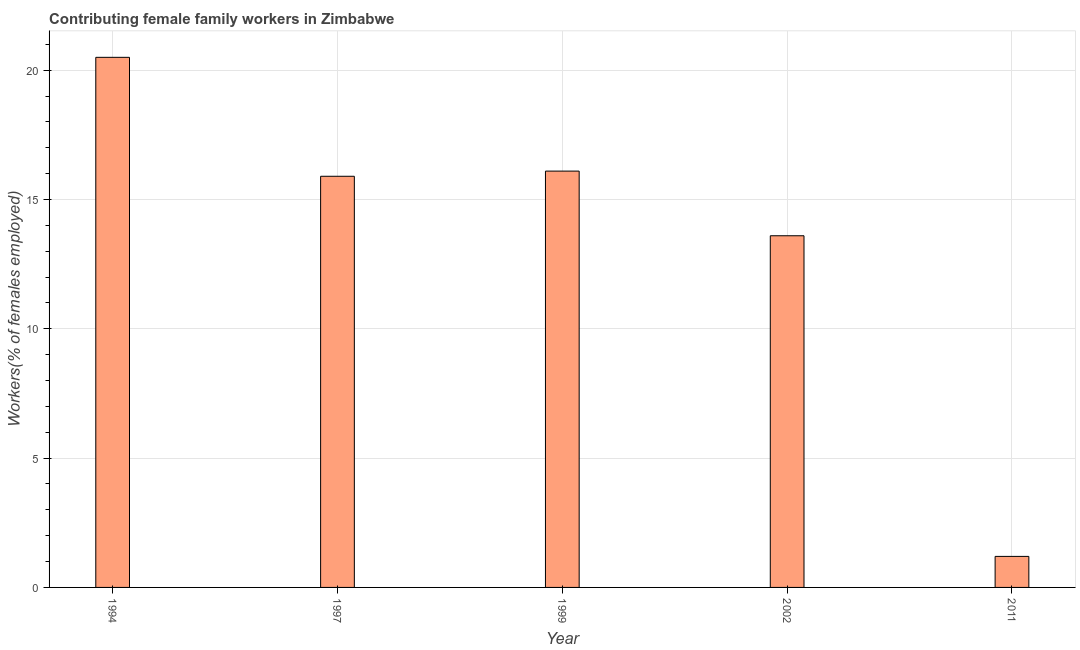Does the graph contain any zero values?
Your answer should be compact. No. What is the title of the graph?
Provide a succinct answer. Contributing female family workers in Zimbabwe. What is the label or title of the Y-axis?
Keep it short and to the point. Workers(% of females employed). What is the contributing female family workers in 2002?
Your answer should be very brief. 13.6. Across all years, what is the maximum contributing female family workers?
Keep it short and to the point. 20.5. Across all years, what is the minimum contributing female family workers?
Provide a short and direct response. 1.2. In which year was the contributing female family workers maximum?
Ensure brevity in your answer.  1994. In which year was the contributing female family workers minimum?
Provide a short and direct response. 2011. What is the sum of the contributing female family workers?
Keep it short and to the point. 67.3. What is the average contributing female family workers per year?
Provide a succinct answer. 13.46. What is the median contributing female family workers?
Ensure brevity in your answer.  15.9. Do a majority of the years between 1999 and 2011 (inclusive) have contributing female family workers greater than 11 %?
Offer a very short reply. Yes. What is the ratio of the contributing female family workers in 1997 to that in 2011?
Provide a short and direct response. 13.25. Is the contributing female family workers in 1999 less than that in 2002?
Your answer should be very brief. No. Is the difference between the contributing female family workers in 2002 and 2011 greater than the difference between any two years?
Give a very brief answer. No. Is the sum of the contributing female family workers in 1997 and 1999 greater than the maximum contributing female family workers across all years?
Your response must be concise. Yes. What is the difference between the highest and the lowest contributing female family workers?
Give a very brief answer. 19.3. In how many years, is the contributing female family workers greater than the average contributing female family workers taken over all years?
Ensure brevity in your answer.  4. How many years are there in the graph?
Give a very brief answer. 5. What is the difference between two consecutive major ticks on the Y-axis?
Give a very brief answer. 5. Are the values on the major ticks of Y-axis written in scientific E-notation?
Your response must be concise. No. What is the Workers(% of females employed) in 1994?
Keep it short and to the point. 20.5. What is the Workers(% of females employed) of 1997?
Your response must be concise. 15.9. What is the Workers(% of females employed) of 1999?
Offer a terse response. 16.1. What is the Workers(% of females employed) of 2002?
Ensure brevity in your answer.  13.6. What is the Workers(% of females employed) in 2011?
Keep it short and to the point. 1.2. What is the difference between the Workers(% of females employed) in 1994 and 2011?
Give a very brief answer. 19.3. What is the difference between the Workers(% of females employed) in 1997 and 1999?
Keep it short and to the point. -0.2. What is the difference between the Workers(% of females employed) in 1997 and 2011?
Offer a terse response. 14.7. What is the difference between the Workers(% of females employed) in 1999 and 2002?
Your response must be concise. 2.5. What is the difference between the Workers(% of females employed) in 2002 and 2011?
Keep it short and to the point. 12.4. What is the ratio of the Workers(% of females employed) in 1994 to that in 1997?
Give a very brief answer. 1.29. What is the ratio of the Workers(% of females employed) in 1994 to that in 1999?
Offer a terse response. 1.27. What is the ratio of the Workers(% of females employed) in 1994 to that in 2002?
Make the answer very short. 1.51. What is the ratio of the Workers(% of females employed) in 1994 to that in 2011?
Offer a very short reply. 17.08. What is the ratio of the Workers(% of females employed) in 1997 to that in 1999?
Provide a short and direct response. 0.99. What is the ratio of the Workers(% of females employed) in 1997 to that in 2002?
Provide a succinct answer. 1.17. What is the ratio of the Workers(% of females employed) in 1997 to that in 2011?
Provide a short and direct response. 13.25. What is the ratio of the Workers(% of females employed) in 1999 to that in 2002?
Provide a succinct answer. 1.18. What is the ratio of the Workers(% of females employed) in 1999 to that in 2011?
Your answer should be compact. 13.42. What is the ratio of the Workers(% of females employed) in 2002 to that in 2011?
Your answer should be very brief. 11.33. 